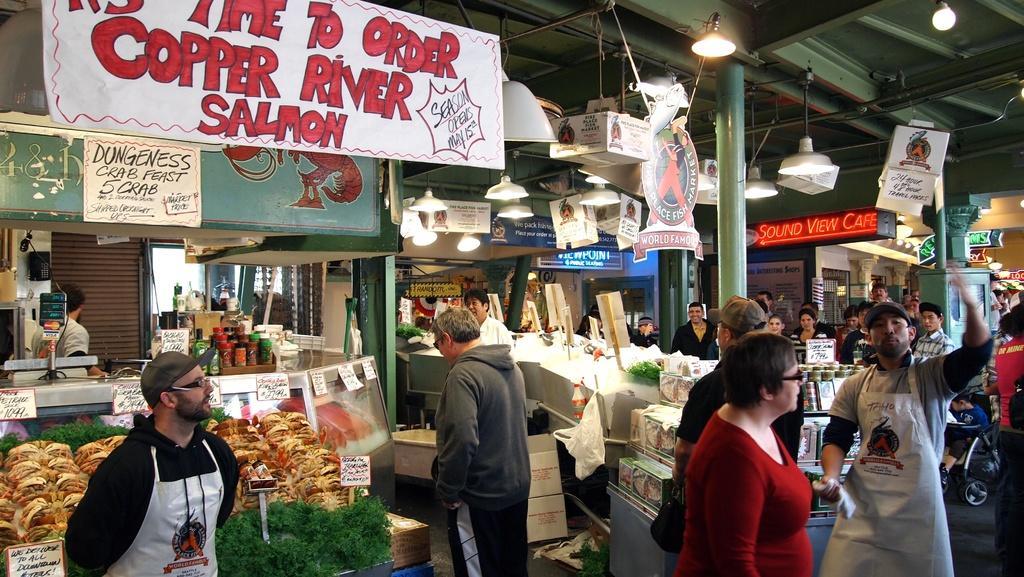Can you describe this image briefly? In this picture we can see group of people, in the background we can find few bottles, boxes, plants, weighing machine, hoardings and lights, on the right side of the image we can see a baby cart and a digital screen. 